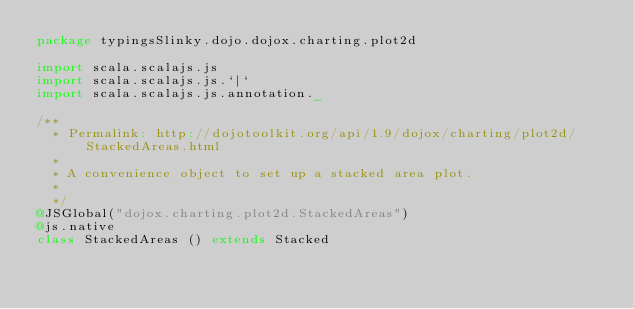<code> <loc_0><loc_0><loc_500><loc_500><_Scala_>package typingsSlinky.dojo.dojox.charting.plot2d

import scala.scalajs.js
import scala.scalajs.js.`|`
import scala.scalajs.js.annotation._

/**
  * Permalink: http://dojotoolkit.org/api/1.9/dojox/charting/plot2d/StackedAreas.html
  *
  * A convenience object to set up a stacked area plot.
  *
  */
@JSGlobal("dojox.charting.plot2d.StackedAreas")
@js.native
class StackedAreas () extends Stacked

</code> 